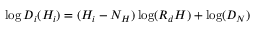<formula> <loc_0><loc_0><loc_500><loc_500>\log D _ { i } ( H _ { i } ) = ( H _ { i } - N _ { H } ) \log ( R _ { d } H ) + \log ( D _ { N } )</formula> 